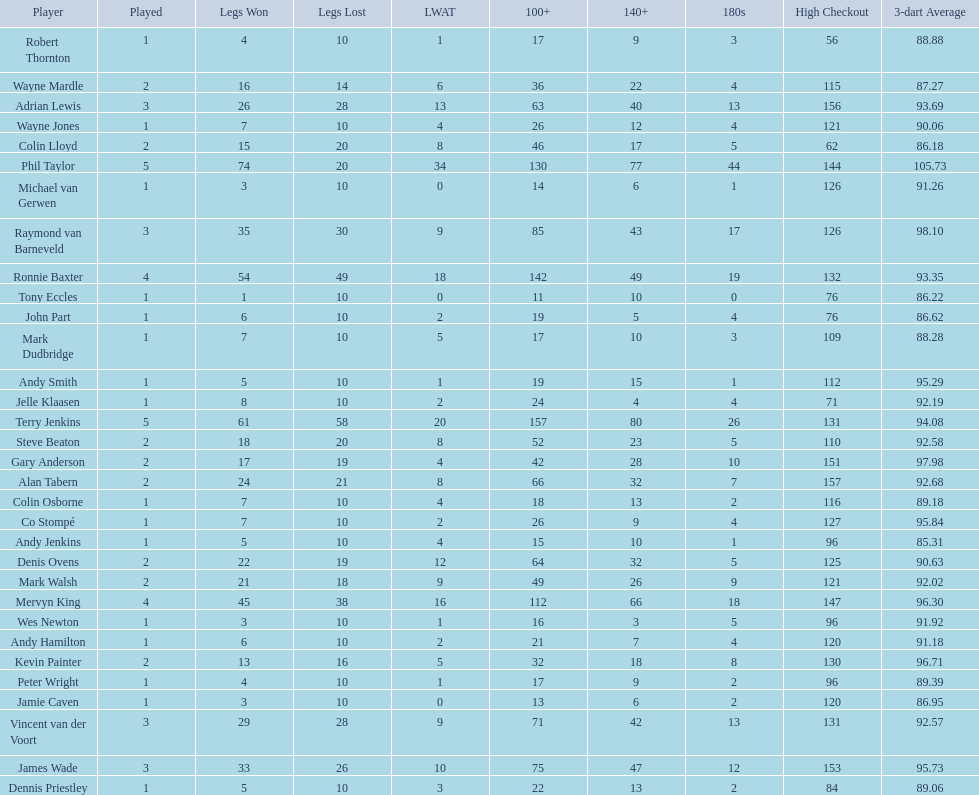Mark walsh's average is above/below 93? Below. 